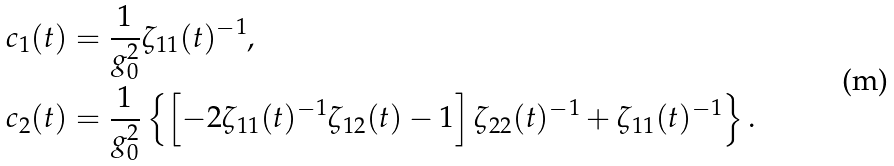<formula> <loc_0><loc_0><loc_500><loc_500>c _ { 1 } ( t ) & = \frac { 1 } { g _ { 0 } ^ { 2 } } \zeta _ { 1 1 } ( t ) ^ { - 1 } , \\ c _ { 2 } ( t ) & = \frac { 1 } { g _ { 0 } ^ { 2 } } \left \{ \left [ - 2 \zeta _ { 1 1 } ( t ) ^ { - 1 } \zeta _ { 1 2 } ( t ) - 1 \right ] \zeta _ { 2 2 } ( t ) ^ { - 1 } + \zeta _ { 1 1 } ( t ) ^ { - 1 } \right \} .</formula> 